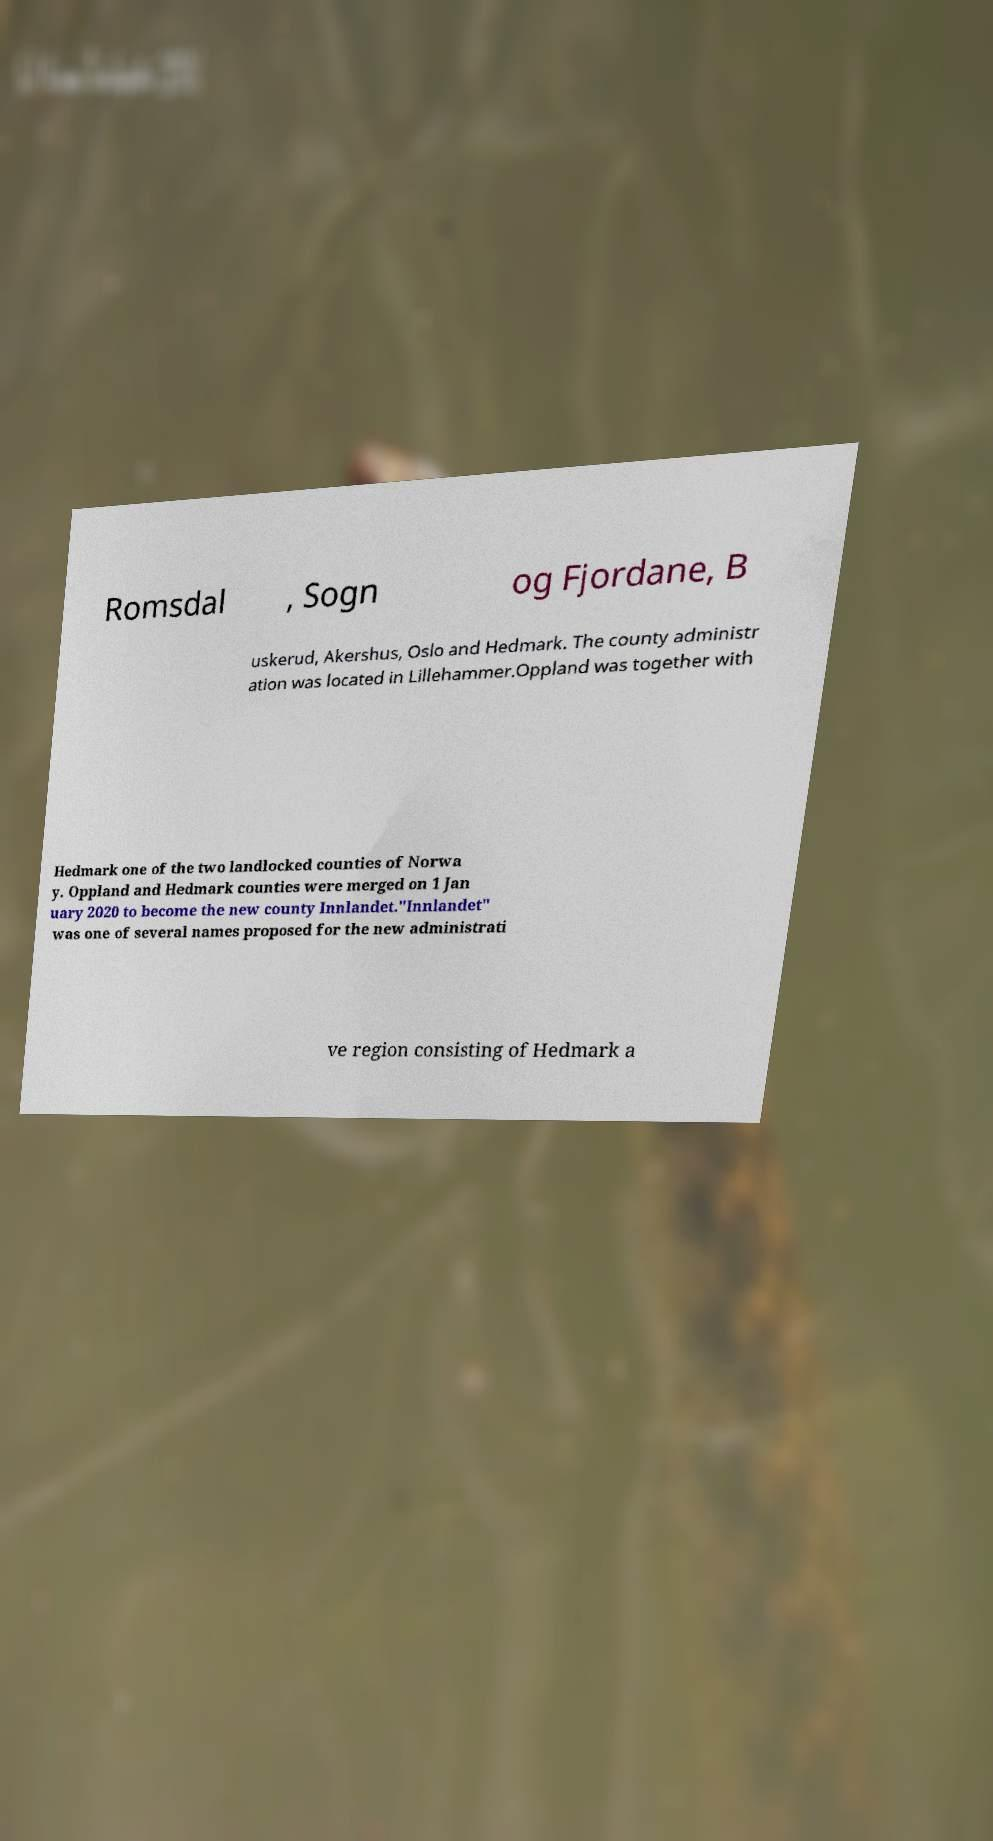Could you extract and type out the text from this image? Romsdal , Sogn og Fjordane, B uskerud, Akershus, Oslo and Hedmark. The county administr ation was located in Lillehammer.Oppland was together with Hedmark one of the two landlocked counties of Norwa y. Oppland and Hedmark counties were merged on 1 Jan uary 2020 to become the new county Innlandet."Innlandet" was one of several names proposed for the new administrati ve region consisting of Hedmark a 